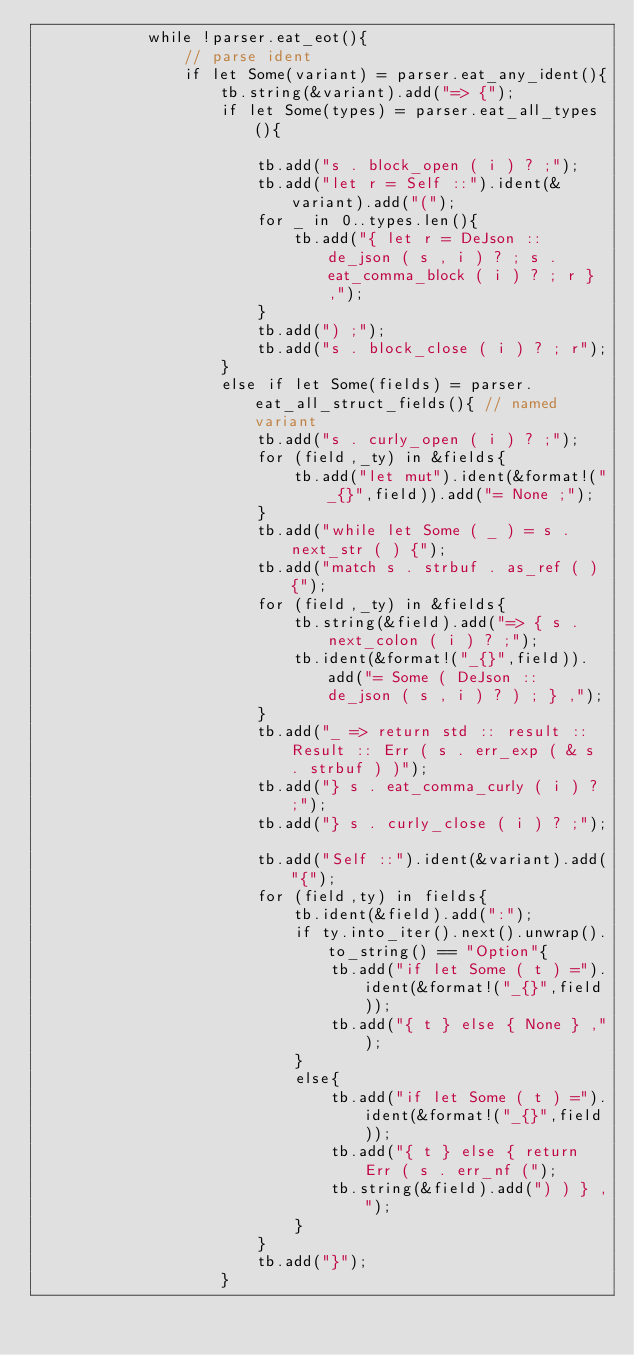<code> <loc_0><loc_0><loc_500><loc_500><_Rust_>            while !parser.eat_eot(){
                // parse ident
                if let Some(variant) = parser.eat_any_ident(){
                    tb.string(&variant).add("=> {");
                    if let Some(types) = parser.eat_all_types(){
                        
                        tb.add("s . block_open ( i ) ? ;");
                        tb.add("let r = Self ::").ident(&variant).add("(");
                        for _ in 0..types.len(){
                            tb.add("{ let r = DeJson :: de_json ( s , i ) ? ; s . eat_comma_block ( i ) ? ; r } ,");
                        }
                        tb.add(") ;");
                        tb.add("s . block_close ( i ) ? ; r");
                    }
                    else if let Some(fields) = parser.eat_all_struct_fields(){ // named variant
                        tb.add("s . curly_open ( i ) ? ;");
                        for (field,_ty) in &fields{
                            tb.add("let mut").ident(&format!("_{}",field)).add("= None ;");
                        }
                        tb.add("while let Some ( _ ) = s . next_str ( ) {");
                        tb.add("match s . strbuf . as_ref ( ) {");
                        for (field,_ty) in &fields{
                            tb.string(&field).add("=> { s . next_colon ( i ) ? ;");
                            tb.ident(&format!("_{}",field)).add("= Some ( DeJson :: de_json ( s , i ) ? ) ; } ,");
                        }
                        tb.add("_ => return std :: result :: Result :: Err ( s . err_exp ( & s . strbuf ) )");
                        tb.add("} s . eat_comma_curly ( i ) ? ;");
                        tb.add("} s . curly_close ( i ) ? ;");
                        
                        tb.add("Self ::").ident(&variant).add("{");
                        for (field,ty) in fields{
                            tb.ident(&field).add(":");
                            if ty.into_iter().next().unwrap().to_string() == "Option"{
                                tb.add("if let Some ( t ) =").ident(&format!("_{}",field));
                                tb.add("{ t } else { None } ,");
                            }
                            else{
                                tb.add("if let Some ( t ) =").ident(&format!("_{}",field));
                                tb.add("{ t } else { return Err ( s . err_nf (");
                                tb.string(&field).add(") ) } ,");
                            }
                        }
                        tb.add("}");
                    }</code> 